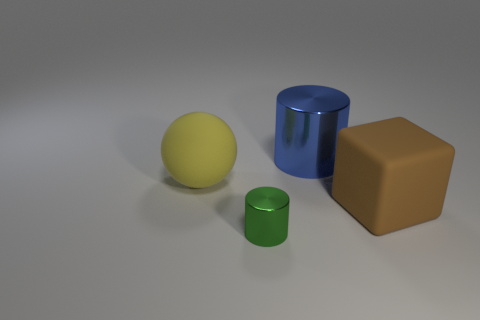Add 2 big balls. How many objects exist? 6 Subtract all blocks. How many objects are left? 3 Subtract 1 green cylinders. How many objects are left? 3 Subtract all blue blocks. Subtract all yellow rubber balls. How many objects are left? 3 Add 2 green metal cylinders. How many green metal cylinders are left? 3 Add 4 large metal things. How many large metal things exist? 5 